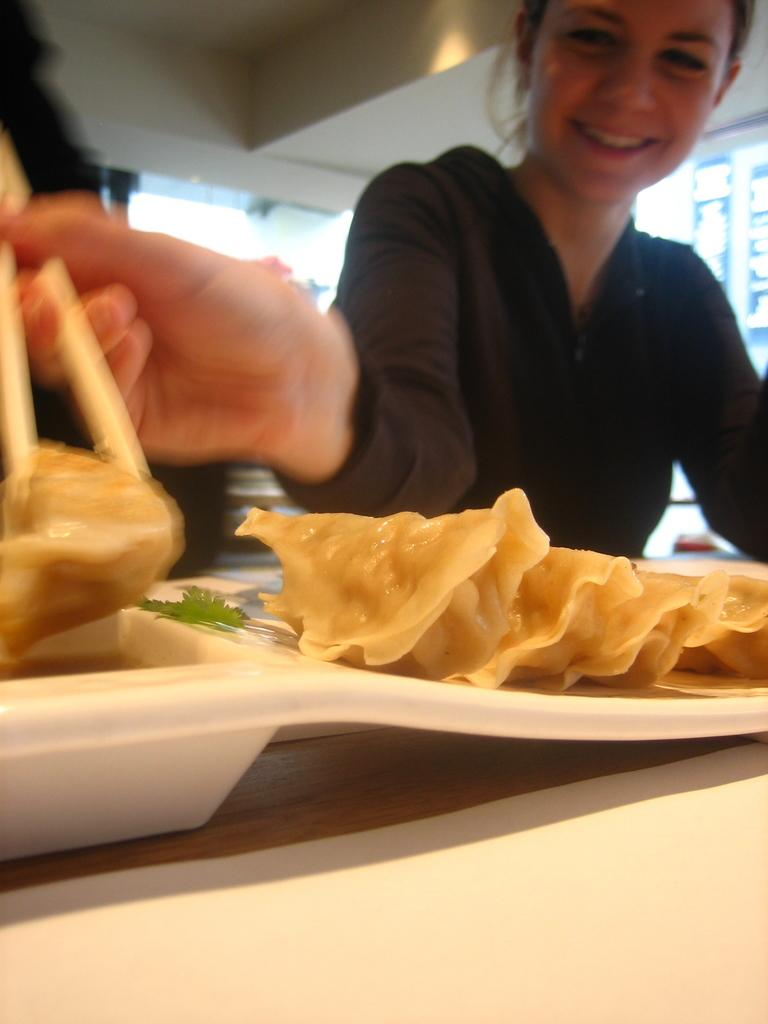Who is the main subject in the image? There is a girl in the image. What is the girl wearing? The girl is wearing a black hoodie. What is the girl holding in the image? The girl is holding momos. How is the girl eating the momos? The girl is using chopsticks. Where are the momos placed? The momos are on a table. What type of farm animals can be seen in the image? There are no farm animals present in the image. How many spiders are crawling on the girl's hoodie in the image? There are no spiders visible on the girl's hoodie in the image. 